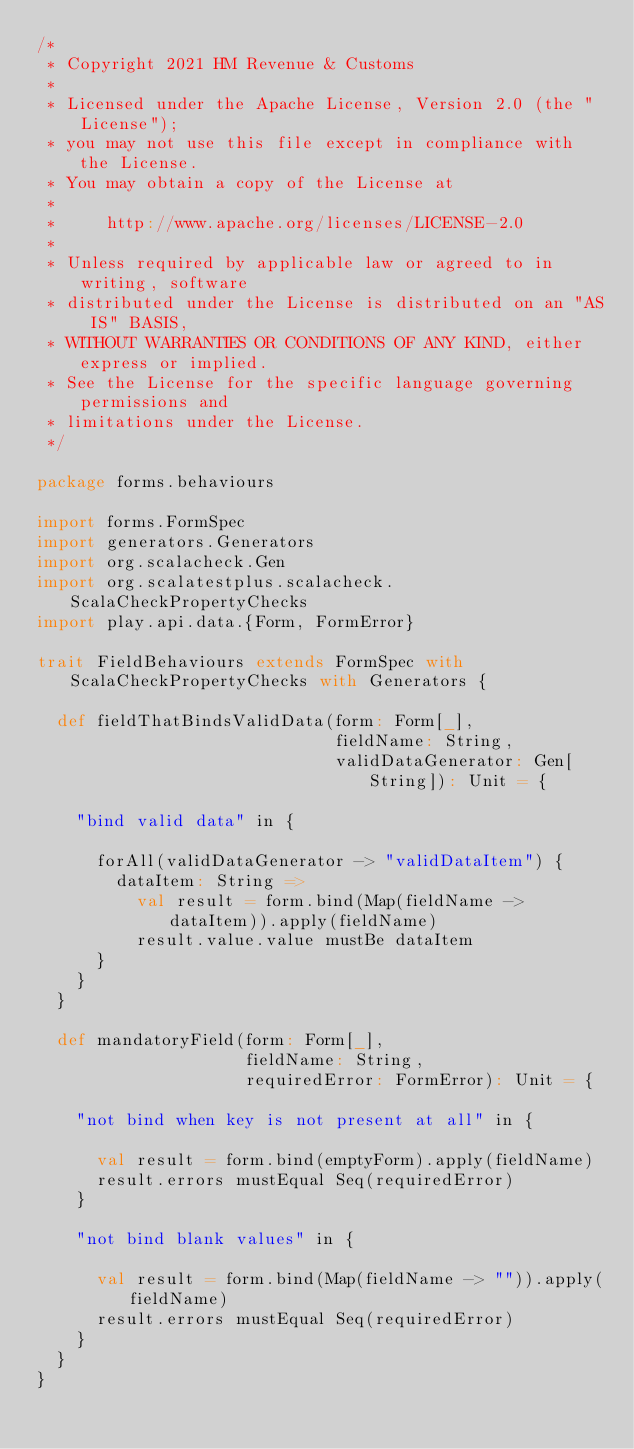Convert code to text. <code><loc_0><loc_0><loc_500><loc_500><_Scala_>/*
 * Copyright 2021 HM Revenue & Customs
 *
 * Licensed under the Apache License, Version 2.0 (the "License");
 * you may not use this file except in compliance with the License.
 * You may obtain a copy of the License at
 *
 *     http://www.apache.org/licenses/LICENSE-2.0
 *
 * Unless required by applicable law or agreed to in writing, software
 * distributed under the License is distributed on an "AS IS" BASIS,
 * WITHOUT WARRANTIES OR CONDITIONS OF ANY KIND, either express or implied.
 * See the License for the specific language governing permissions and
 * limitations under the License.
 */

package forms.behaviours

import forms.FormSpec
import generators.Generators
import org.scalacheck.Gen
import org.scalatestplus.scalacheck.ScalaCheckPropertyChecks
import play.api.data.{Form, FormError}

trait FieldBehaviours extends FormSpec with ScalaCheckPropertyChecks with Generators {

  def fieldThatBindsValidData(form: Form[_],
                              fieldName: String,
                              validDataGenerator: Gen[String]): Unit = {

    "bind valid data" in {

      forAll(validDataGenerator -> "validDataItem") {
        dataItem: String =>
          val result = form.bind(Map(fieldName -> dataItem)).apply(fieldName)
          result.value.value mustBe dataItem
      }
    }
  }

  def mandatoryField(form: Form[_],
                     fieldName: String,
                     requiredError: FormError): Unit = {

    "not bind when key is not present at all" in {

      val result = form.bind(emptyForm).apply(fieldName)
      result.errors mustEqual Seq(requiredError)
    }

    "not bind blank values" in {

      val result = form.bind(Map(fieldName -> "")).apply(fieldName)
      result.errors mustEqual Seq(requiredError)
    }
  }
}
</code> 